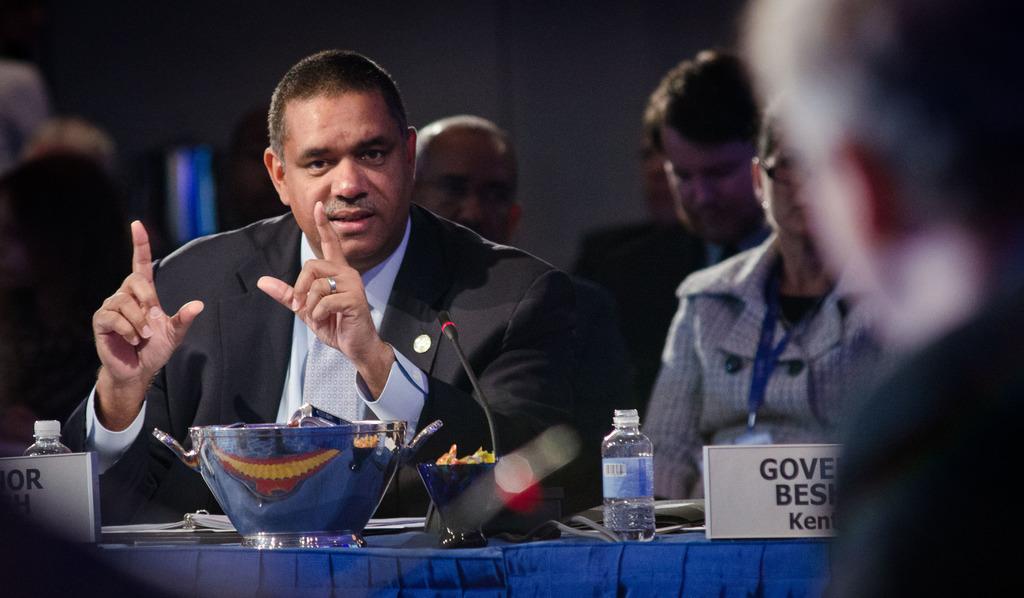How would you summarize this image in a sentence or two? In this picture there are people and we can see name boards, microphone, bottles and objects on the table. In the background of the image it is blurry. 